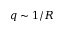<formula> <loc_0><loc_0><loc_500><loc_500>q \sim 1 / R</formula> 